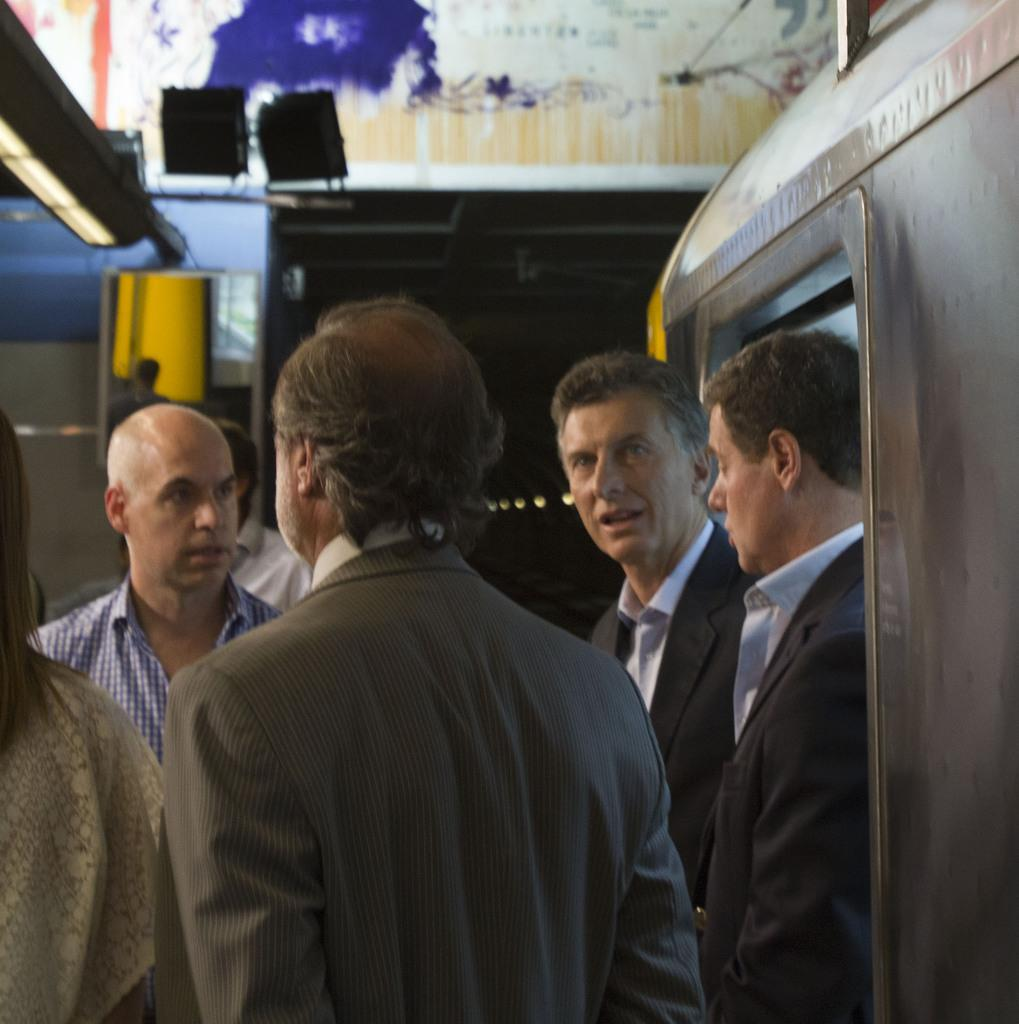What is happening in the foreground of the image? There is a group of people in the foreground of the image, and they are standing and talking. Can you describe the lights visible at the top of the image? Yes, there are lights visible at the top of the image. What is the poster at the top of the image about? Unfortunately, the content of the poster cannot be determined from the image. What type of grain is being cooked on the stove in the image? There is no stove or grain present in the image. How many wheels can be seen on the vehicles in the image? There are no vehicles or wheels present in the image. 